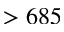<formula> <loc_0><loc_0><loc_500><loc_500>> 6 8 5</formula> 